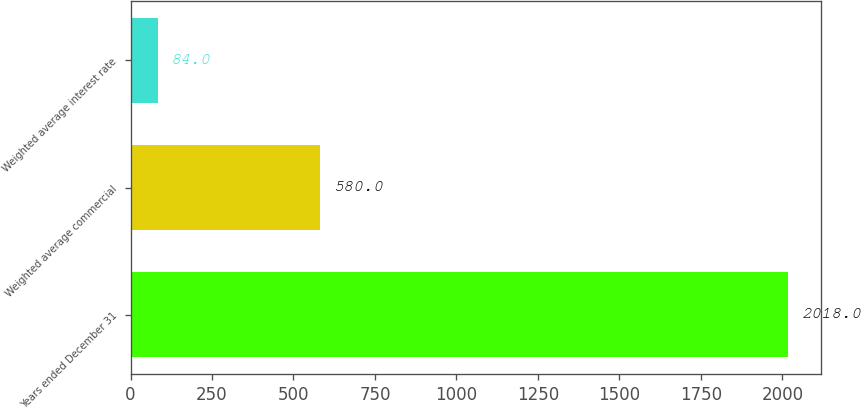Convert chart to OTSL. <chart><loc_0><loc_0><loc_500><loc_500><bar_chart><fcel>Years ended December 31<fcel>Weighted average commercial<fcel>Weighted average interest rate<nl><fcel>2018<fcel>580<fcel>84<nl></chart> 